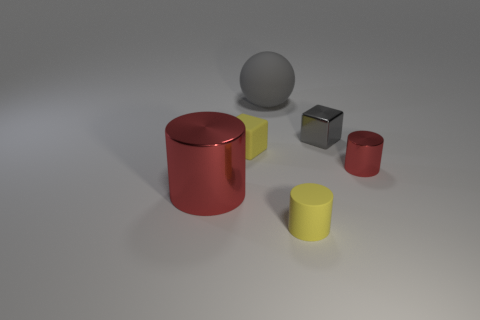There is a small cylinder that is the same material as the big red cylinder; what color is it?
Ensure brevity in your answer.  Red. Does the tiny matte thing in front of the large red shiny cylinder have the same color as the metal object left of the tiny gray metal block?
Offer a terse response. No. How many spheres are either tiny cyan objects or tiny yellow objects?
Ensure brevity in your answer.  0. Is the number of tiny objects on the right side of the metallic block the same as the number of tiny red cylinders?
Provide a short and direct response. Yes. The yellow object that is to the left of the large gray matte sphere that is behind the red object that is in front of the small red metal object is made of what material?
Your response must be concise. Rubber. There is a cube that is the same color as the sphere; what material is it?
Your answer should be compact. Metal. What number of things are either red cylinders to the right of the tiny gray shiny thing or green things?
Provide a succinct answer. 1. How many objects are tiny yellow matte cylinders or small yellow things that are behind the large metallic thing?
Provide a succinct answer. 2. How many tiny cylinders are to the left of the small cylinder that is in front of the big object that is in front of the small gray block?
Provide a short and direct response. 0. There is a red object that is the same size as the gray matte object; what is it made of?
Provide a short and direct response. Metal. 